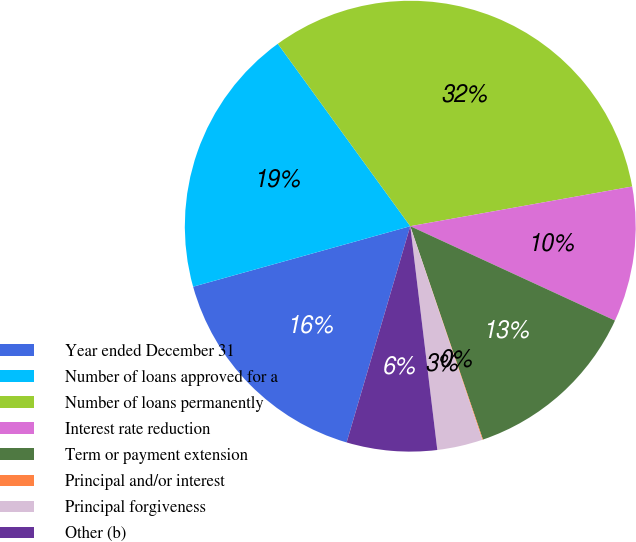Convert chart. <chart><loc_0><loc_0><loc_500><loc_500><pie_chart><fcel>Year ended December 31<fcel>Number of loans approved for a<fcel>Number of loans permanently<fcel>Interest rate reduction<fcel>Term or payment extension<fcel>Principal and/or interest<fcel>Principal forgiveness<fcel>Other (b)<nl><fcel>16.12%<fcel>19.33%<fcel>32.18%<fcel>9.69%<fcel>12.9%<fcel>0.05%<fcel>3.26%<fcel>6.47%<nl></chart> 